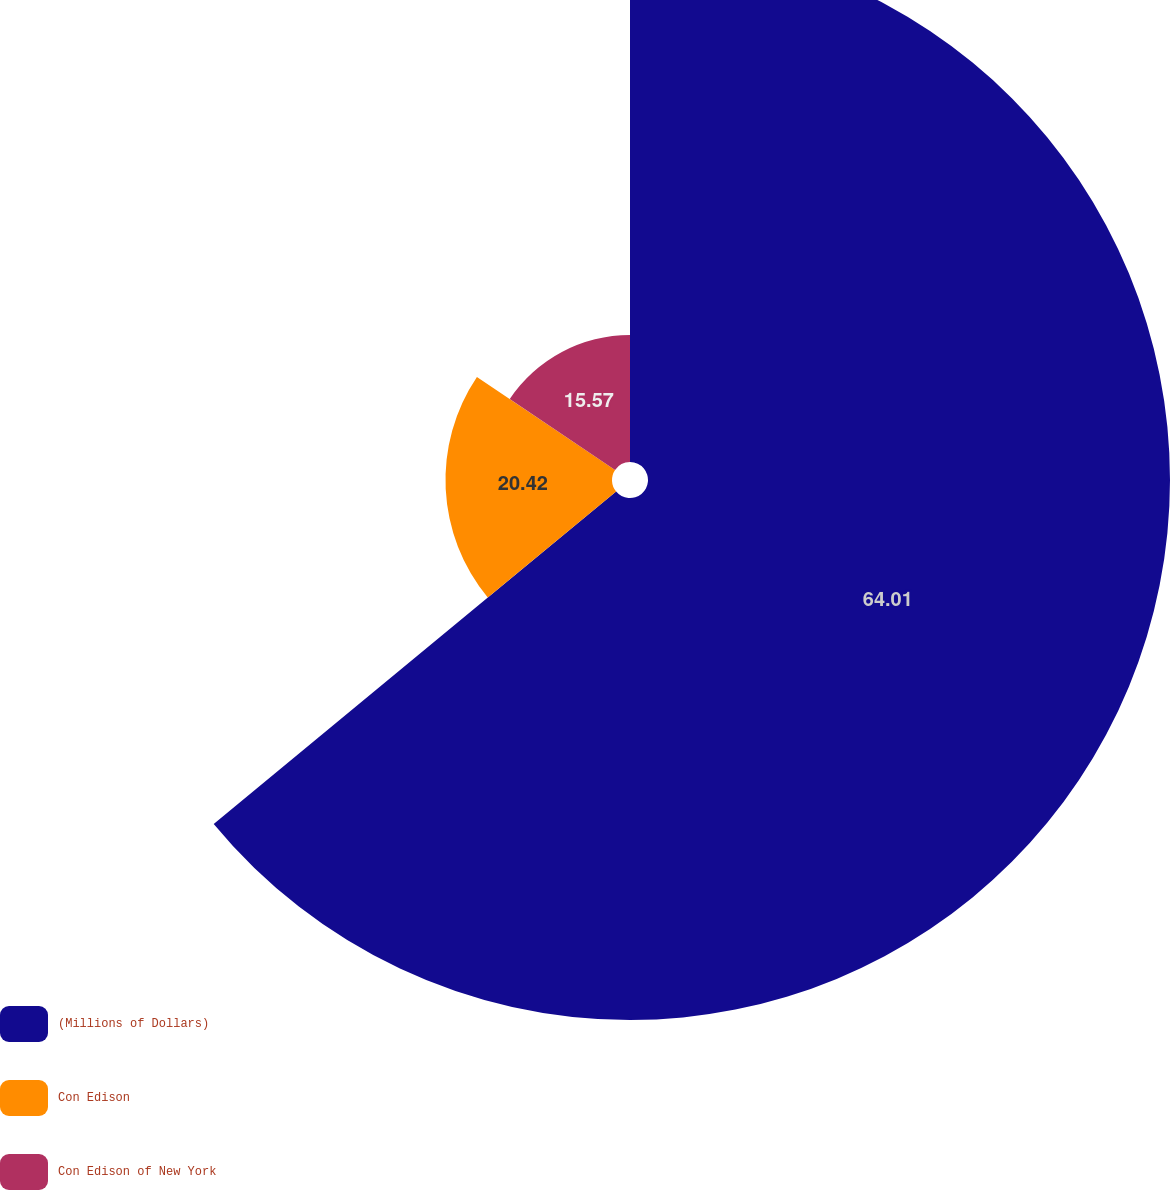Convert chart. <chart><loc_0><loc_0><loc_500><loc_500><pie_chart><fcel>(Millions of Dollars)<fcel>Con Edison<fcel>Con Edison of New York<nl><fcel>64.01%<fcel>20.42%<fcel>15.57%<nl></chart> 